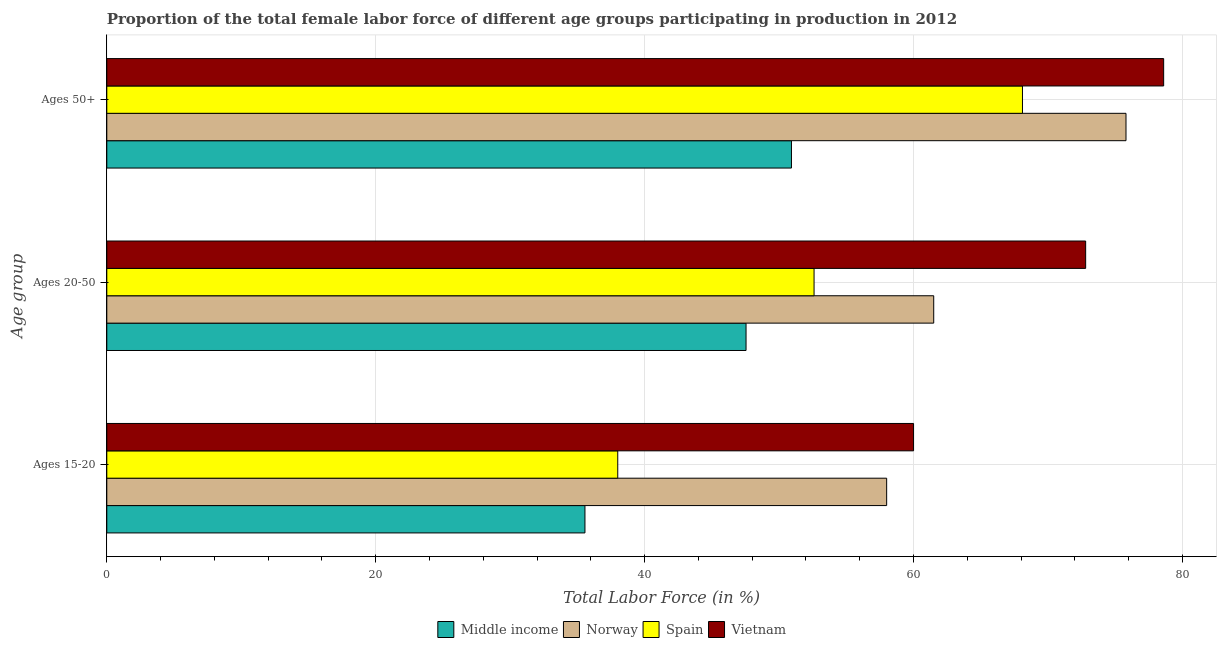How many different coloured bars are there?
Keep it short and to the point. 4. How many groups of bars are there?
Your answer should be compact. 3. Are the number of bars on each tick of the Y-axis equal?
Offer a very short reply. Yes. How many bars are there on the 1st tick from the top?
Your answer should be compact. 4. What is the label of the 1st group of bars from the top?
Your answer should be compact. Ages 50+. What is the percentage of female labor force within the age group 15-20 in Spain?
Ensure brevity in your answer.  38. Across all countries, what is the maximum percentage of female labor force within the age group 20-50?
Provide a succinct answer. 72.8. Across all countries, what is the minimum percentage of female labor force above age 50?
Your response must be concise. 50.92. In which country was the percentage of female labor force above age 50 maximum?
Provide a short and direct response. Vietnam. What is the total percentage of female labor force above age 50 in the graph?
Make the answer very short. 273.42. What is the difference between the percentage of female labor force above age 50 in Vietnam and that in Middle income?
Offer a terse response. 27.68. What is the difference between the percentage of female labor force within the age group 15-20 in Spain and the percentage of female labor force within the age group 20-50 in Vietnam?
Offer a terse response. -34.8. What is the average percentage of female labor force within the age group 20-50 per country?
Your answer should be compact. 58.61. What is the difference between the percentage of female labor force within the age group 15-20 and percentage of female labor force above age 50 in Middle income?
Provide a short and direct response. -15.36. What is the ratio of the percentage of female labor force within the age group 20-50 in Vietnam to that in Norway?
Ensure brevity in your answer.  1.18. Is the percentage of female labor force above age 50 in Norway less than that in Spain?
Your answer should be very brief. No. Is the difference between the percentage of female labor force within the age group 20-50 in Vietnam and Middle income greater than the difference between the percentage of female labor force above age 50 in Vietnam and Middle income?
Make the answer very short. No. What is the difference between the highest and the lowest percentage of female labor force within the age group 20-50?
Your answer should be compact. 25.26. What does the 3rd bar from the top in Ages 15-20 represents?
Give a very brief answer. Norway. What does the 4th bar from the bottom in Ages 50+ represents?
Your answer should be very brief. Vietnam. Is it the case that in every country, the sum of the percentage of female labor force within the age group 15-20 and percentage of female labor force within the age group 20-50 is greater than the percentage of female labor force above age 50?
Offer a terse response. Yes. What is the difference between two consecutive major ticks on the X-axis?
Give a very brief answer. 20. Are the values on the major ticks of X-axis written in scientific E-notation?
Your answer should be very brief. No. Does the graph contain any zero values?
Give a very brief answer. No. Does the graph contain grids?
Provide a short and direct response. Yes. Where does the legend appear in the graph?
Your response must be concise. Bottom center. How many legend labels are there?
Give a very brief answer. 4. How are the legend labels stacked?
Make the answer very short. Horizontal. What is the title of the graph?
Make the answer very short. Proportion of the total female labor force of different age groups participating in production in 2012. What is the label or title of the X-axis?
Your response must be concise. Total Labor Force (in %). What is the label or title of the Y-axis?
Give a very brief answer. Age group. What is the Total Labor Force (in %) of Middle income in Ages 15-20?
Your response must be concise. 35.56. What is the Total Labor Force (in %) of Middle income in Ages 20-50?
Your answer should be compact. 47.54. What is the Total Labor Force (in %) in Norway in Ages 20-50?
Make the answer very short. 61.5. What is the Total Labor Force (in %) in Spain in Ages 20-50?
Provide a short and direct response. 52.6. What is the Total Labor Force (in %) in Vietnam in Ages 20-50?
Your answer should be very brief. 72.8. What is the Total Labor Force (in %) in Middle income in Ages 50+?
Give a very brief answer. 50.92. What is the Total Labor Force (in %) of Norway in Ages 50+?
Keep it short and to the point. 75.8. What is the Total Labor Force (in %) in Spain in Ages 50+?
Provide a short and direct response. 68.1. What is the Total Labor Force (in %) of Vietnam in Ages 50+?
Offer a very short reply. 78.6. Across all Age group, what is the maximum Total Labor Force (in %) in Middle income?
Give a very brief answer. 50.92. Across all Age group, what is the maximum Total Labor Force (in %) of Norway?
Provide a short and direct response. 75.8. Across all Age group, what is the maximum Total Labor Force (in %) in Spain?
Keep it short and to the point. 68.1. Across all Age group, what is the maximum Total Labor Force (in %) in Vietnam?
Offer a very short reply. 78.6. Across all Age group, what is the minimum Total Labor Force (in %) of Middle income?
Your answer should be compact. 35.56. Across all Age group, what is the minimum Total Labor Force (in %) of Spain?
Provide a succinct answer. 38. What is the total Total Labor Force (in %) of Middle income in the graph?
Offer a terse response. 134.02. What is the total Total Labor Force (in %) in Norway in the graph?
Provide a short and direct response. 195.3. What is the total Total Labor Force (in %) in Spain in the graph?
Offer a very short reply. 158.7. What is the total Total Labor Force (in %) of Vietnam in the graph?
Provide a short and direct response. 211.4. What is the difference between the Total Labor Force (in %) of Middle income in Ages 15-20 and that in Ages 20-50?
Keep it short and to the point. -11.98. What is the difference between the Total Labor Force (in %) of Spain in Ages 15-20 and that in Ages 20-50?
Give a very brief answer. -14.6. What is the difference between the Total Labor Force (in %) in Vietnam in Ages 15-20 and that in Ages 20-50?
Give a very brief answer. -12.8. What is the difference between the Total Labor Force (in %) of Middle income in Ages 15-20 and that in Ages 50+?
Keep it short and to the point. -15.36. What is the difference between the Total Labor Force (in %) of Norway in Ages 15-20 and that in Ages 50+?
Ensure brevity in your answer.  -17.8. What is the difference between the Total Labor Force (in %) in Spain in Ages 15-20 and that in Ages 50+?
Your response must be concise. -30.1. What is the difference between the Total Labor Force (in %) of Vietnam in Ages 15-20 and that in Ages 50+?
Offer a very short reply. -18.6. What is the difference between the Total Labor Force (in %) in Middle income in Ages 20-50 and that in Ages 50+?
Provide a short and direct response. -3.38. What is the difference between the Total Labor Force (in %) in Norway in Ages 20-50 and that in Ages 50+?
Give a very brief answer. -14.3. What is the difference between the Total Labor Force (in %) in Spain in Ages 20-50 and that in Ages 50+?
Keep it short and to the point. -15.5. What is the difference between the Total Labor Force (in %) of Middle income in Ages 15-20 and the Total Labor Force (in %) of Norway in Ages 20-50?
Provide a succinct answer. -25.94. What is the difference between the Total Labor Force (in %) of Middle income in Ages 15-20 and the Total Labor Force (in %) of Spain in Ages 20-50?
Offer a very short reply. -17.04. What is the difference between the Total Labor Force (in %) in Middle income in Ages 15-20 and the Total Labor Force (in %) in Vietnam in Ages 20-50?
Your answer should be very brief. -37.24. What is the difference between the Total Labor Force (in %) of Norway in Ages 15-20 and the Total Labor Force (in %) of Spain in Ages 20-50?
Provide a short and direct response. 5.4. What is the difference between the Total Labor Force (in %) of Norway in Ages 15-20 and the Total Labor Force (in %) of Vietnam in Ages 20-50?
Your answer should be very brief. -14.8. What is the difference between the Total Labor Force (in %) in Spain in Ages 15-20 and the Total Labor Force (in %) in Vietnam in Ages 20-50?
Offer a terse response. -34.8. What is the difference between the Total Labor Force (in %) in Middle income in Ages 15-20 and the Total Labor Force (in %) in Norway in Ages 50+?
Make the answer very short. -40.24. What is the difference between the Total Labor Force (in %) of Middle income in Ages 15-20 and the Total Labor Force (in %) of Spain in Ages 50+?
Give a very brief answer. -32.54. What is the difference between the Total Labor Force (in %) in Middle income in Ages 15-20 and the Total Labor Force (in %) in Vietnam in Ages 50+?
Provide a short and direct response. -43.04. What is the difference between the Total Labor Force (in %) in Norway in Ages 15-20 and the Total Labor Force (in %) in Spain in Ages 50+?
Give a very brief answer. -10.1. What is the difference between the Total Labor Force (in %) in Norway in Ages 15-20 and the Total Labor Force (in %) in Vietnam in Ages 50+?
Ensure brevity in your answer.  -20.6. What is the difference between the Total Labor Force (in %) in Spain in Ages 15-20 and the Total Labor Force (in %) in Vietnam in Ages 50+?
Offer a terse response. -40.6. What is the difference between the Total Labor Force (in %) of Middle income in Ages 20-50 and the Total Labor Force (in %) of Norway in Ages 50+?
Provide a short and direct response. -28.26. What is the difference between the Total Labor Force (in %) in Middle income in Ages 20-50 and the Total Labor Force (in %) in Spain in Ages 50+?
Give a very brief answer. -20.56. What is the difference between the Total Labor Force (in %) in Middle income in Ages 20-50 and the Total Labor Force (in %) in Vietnam in Ages 50+?
Ensure brevity in your answer.  -31.06. What is the difference between the Total Labor Force (in %) in Norway in Ages 20-50 and the Total Labor Force (in %) in Spain in Ages 50+?
Your response must be concise. -6.6. What is the difference between the Total Labor Force (in %) of Norway in Ages 20-50 and the Total Labor Force (in %) of Vietnam in Ages 50+?
Provide a short and direct response. -17.1. What is the average Total Labor Force (in %) in Middle income per Age group?
Offer a very short reply. 44.67. What is the average Total Labor Force (in %) in Norway per Age group?
Ensure brevity in your answer.  65.1. What is the average Total Labor Force (in %) in Spain per Age group?
Provide a short and direct response. 52.9. What is the average Total Labor Force (in %) of Vietnam per Age group?
Give a very brief answer. 70.47. What is the difference between the Total Labor Force (in %) in Middle income and Total Labor Force (in %) in Norway in Ages 15-20?
Offer a very short reply. -22.44. What is the difference between the Total Labor Force (in %) in Middle income and Total Labor Force (in %) in Spain in Ages 15-20?
Offer a terse response. -2.44. What is the difference between the Total Labor Force (in %) in Middle income and Total Labor Force (in %) in Vietnam in Ages 15-20?
Provide a short and direct response. -24.44. What is the difference between the Total Labor Force (in %) in Spain and Total Labor Force (in %) in Vietnam in Ages 15-20?
Offer a terse response. -22. What is the difference between the Total Labor Force (in %) of Middle income and Total Labor Force (in %) of Norway in Ages 20-50?
Provide a succinct answer. -13.96. What is the difference between the Total Labor Force (in %) in Middle income and Total Labor Force (in %) in Spain in Ages 20-50?
Give a very brief answer. -5.06. What is the difference between the Total Labor Force (in %) in Middle income and Total Labor Force (in %) in Vietnam in Ages 20-50?
Provide a succinct answer. -25.26. What is the difference between the Total Labor Force (in %) of Norway and Total Labor Force (in %) of Spain in Ages 20-50?
Offer a very short reply. 8.9. What is the difference between the Total Labor Force (in %) in Norway and Total Labor Force (in %) in Vietnam in Ages 20-50?
Make the answer very short. -11.3. What is the difference between the Total Labor Force (in %) of Spain and Total Labor Force (in %) of Vietnam in Ages 20-50?
Offer a very short reply. -20.2. What is the difference between the Total Labor Force (in %) of Middle income and Total Labor Force (in %) of Norway in Ages 50+?
Your answer should be very brief. -24.88. What is the difference between the Total Labor Force (in %) in Middle income and Total Labor Force (in %) in Spain in Ages 50+?
Your answer should be compact. -17.18. What is the difference between the Total Labor Force (in %) in Middle income and Total Labor Force (in %) in Vietnam in Ages 50+?
Make the answer very short. -27.68. What is the ratio of the Total Labor Force (in %) in Middle income in Ages 15-20 to that in Ages 20-50?
Your response must be concise. 0.75. What is the ratio of the Total Labor Force (in %) of Norway in Ages 15-20 to that in Ages 20-50?
Your answer should be very brief. 0.94. What is the ratio of the Total Labor Force (in %) of Spain in Ages 15-20 to that in Ages 20-50?
Provide a short and direct response. 0.72. What is the ratio of the Total Labor Force (in %) of Vietnam in Ages 15-20 to that in Ages 20-50?
Ensure brevity in your answer.  0.82. What is the ratio of the Total Labor Force (in %) of Middle income in Ages 15-20 to that in Ages 50+?
Provide a short and direct response. 0.7. What is the ratio of the Total Labor Force (in %) of Norway in Ages 15-20 to that in Ages 50+?
Provide a short and direct response. 0.77. What is the ratio of the Total Labor Force (in %) in Spain in Ages 15-20 to that in Ages 50+?
Your answer should be compact. 0.56. What is the ratio of the Total Labor Force (in %) of Vietnam in Ages 15-20 to that in Ages 50+?
Offer a terse response. 0.76. What is the ratio of the Total Labor Force (in %) in Middle income in Ages 20-50 to that in Ages 50+?
Offer a terse response. 0.93. What is the ratio of the Total Labor Force (in %) in Norway in Ages 20-50 to that in Ages 50+?
Give a very brief answer. 0.81. What is the ratio of the Total Labor Force (in %) of Spain in Ages 20-50 to that in Ages 50+?
Provide a short and direct response. 0.77. What is the ratio of the Total Labor Force (in %) of Vietnam in Ages 20-50 to that in Ages 50+?
Ensure brevity in your answer.  0.93. What is the difference between the highest and the second highest Total Labor Force (in %) in Middle income?
Provide a succinct answer. 3.38. What is the difference between the highest and the second highest Total Labor Force (in %) in Norway?
Your answer should be compact. 14.3. What is the difference between the highest and the second highest Total Labor Force (in %) in Spain?
Keep it short and to the point. 15.5. What is the difference between the highest and the second highest Total Labor Force (in %) in Vietnam?
Your response must be concise. 5.8. What is the difference between the highest and the lowest Total Labor Force (in %) in Middle income?
Provide a succinct answer. 15.36. What is the difference between the highest and the lowest Total Labor Force (in %) in Spain?
Offer a terse response. 30.1. 